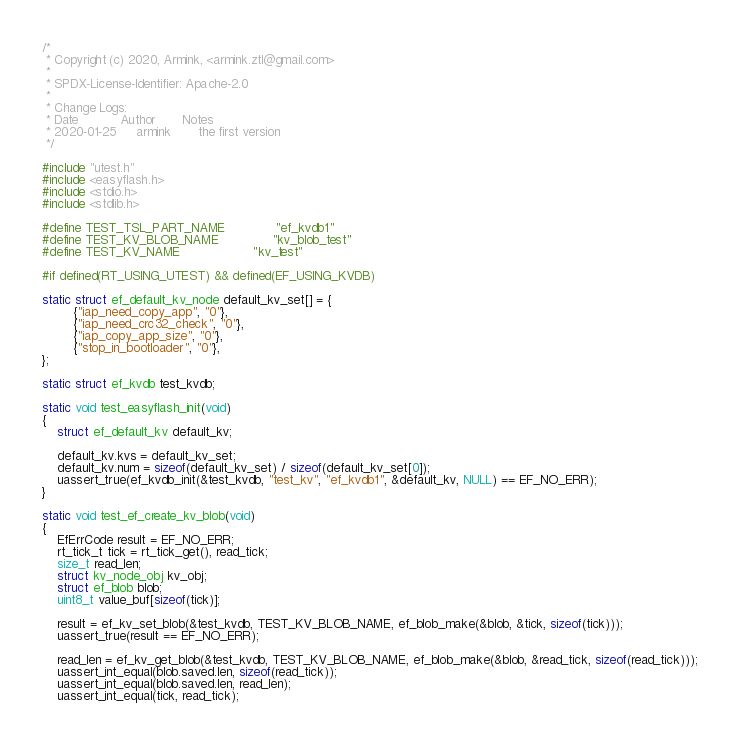<code> <loc_0><loc_0><loc_500><loc_500><_C_>/*
 * Copyright (c) 2020, Armink, <armink.ztl@gmail.com>
 *
 * SPDX-License-Identifier: Apache-2.0
 *
 * Change Logs:
 * Date           Author       Notes
 * 2020-01-25     armink       the first version
 */

#include "utest.h"
#include <easyflash.h>
#include <stdio.h>
#include <stdlib.h>

#define TEST_TSL_PART_NAME             "ef_kvdb1"
#define TEST_KV_BLOB_NAME              "kv_blob_test"
#define TEST_KV_NAME                   "kv_test"

#if defined(RT_USING_UTEST) && defined(EF_USING_KVDB)

static struct ef_default_kv_node default_kv_set[] = {
        {"iap_need_copy_app", "0"},
        {"iap_need_crc32_check", "0"},
        {"iap_copy_app_size", "0"},
        {"stop_in_bootloader", "0"},
};

static struct ef_kvdb test_kvdb;

static void test_easyflash_init(void)
{
    struct ef_default_kv default_kv;

    default_kv.kvs = default_kv_set;
    default_kv.num = sizeof(default_kv_set) / sizeof(default_kv_set[0]);
    uassert_true(ef_kvdb_init(&test_kvdb, "test_kv", "ef_kvdb1", &default_kv, NULL) == EF_NO_ERR);
}

static void test_ef_create_kv_blob(void)
{
    EfErrCode result = EF_NO_ERR;
    rt_tick_t tick = rt_tick_get(), read_tick;
    size_t read_len;
    struct kv_node_obj kv_obj;
    struct ef_blob blob;
    uint8_t value_buf[sizeof(tick)];

    result = ef_kv_set_blob(&test_kvdb, TEST_KV_BLOB_NAME, ef_blob_make(&blob, &tick, sizeof(tick)));
    uassert_true(result == EF_NO_ERR);

    read_len = ef_kv_get_blob(&test_kvdb, TEST_KV_BLOB_NAME, ef_blob_make(&blob, &read_tick, sizeof(read_tick)));
    uassert_int_equal(blob.saved.len, sizeof(read_tick));
    uassert_int_equal(blob.saved.len, read_len);
    uassert_int_equal(tick, read_tick);
</code> 